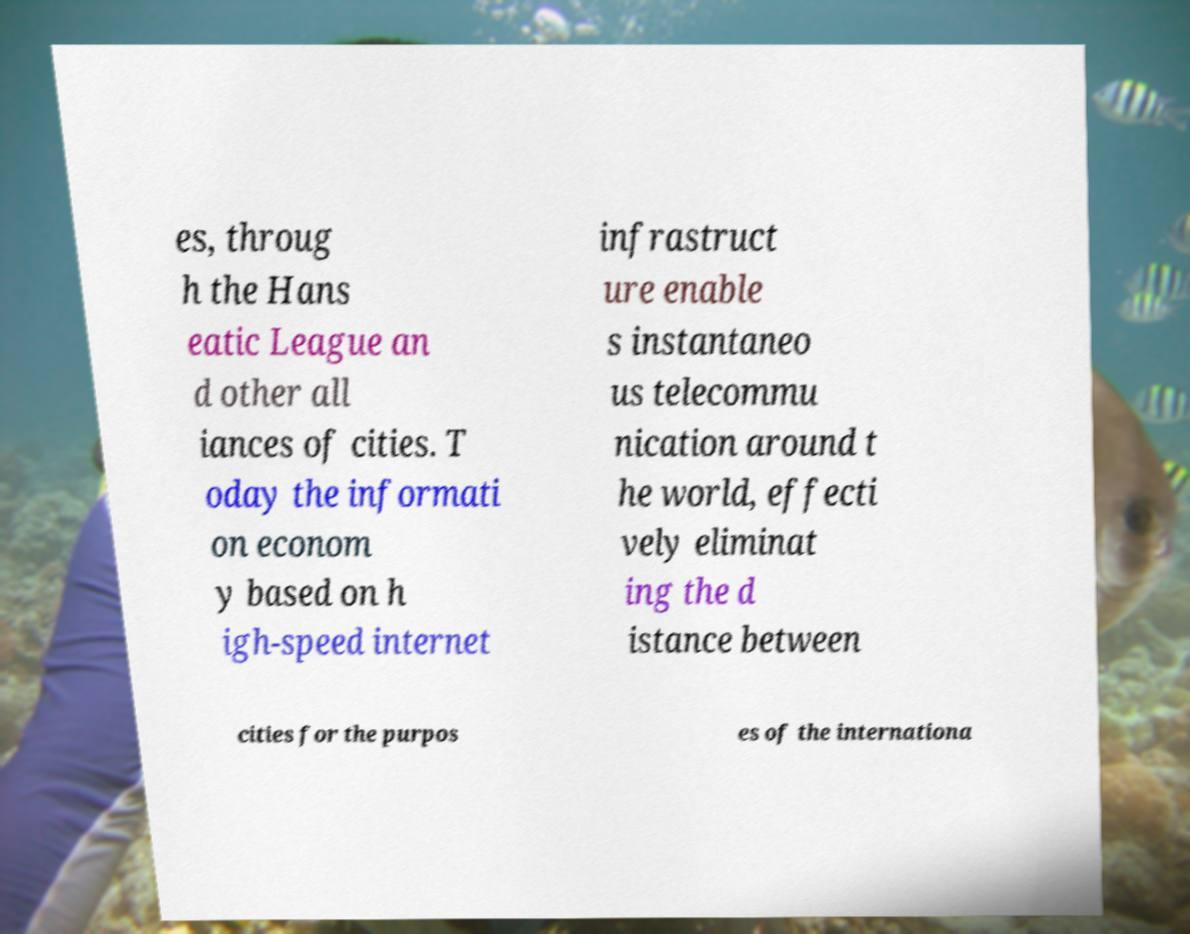Can you read and provide the text displayed in the image?This photo seems to have some interesting text. Can you extract and type it out for me? es, throug h the Hans eatic League an d other all iances of cities. T oday the informati on econom y based on h igh-speed internet infrastruct ure enable s instantaneo us telecommu nication around t he world, effecti vely eliminat ing the d istance between cities for the purpos es of the internationa 